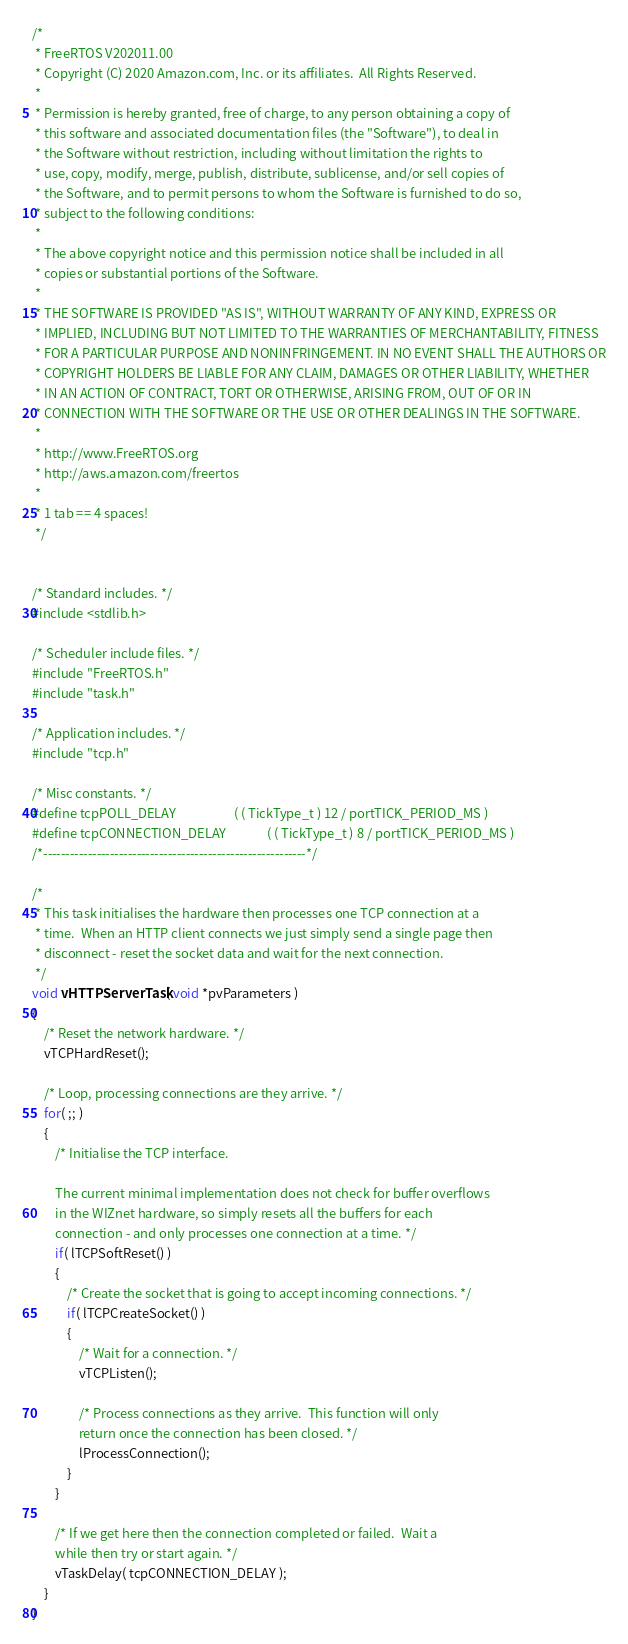<code> <loc_0><loc_0><loc_500><loc_500><_C_>/*
 * FreeRTOS V202011.00
 * Copyright (C) 2020 Amazon.com, Inc. or its affiliates.  All Rights Reserved.
 *
 * Permission is hereby granted, free of charge, to any person obtaining a copy of
 * this software and associated documentation files (the "Software"), to deal in
 * the Software without restriction, including without limitation the rights to
 * use, copy, modify, merge, publish, distribute, sublicense, and/or sell copies of
 * the Software, and to permit persons to whom the Software is furnished to do so,
 * subject to the following conditions:
 *
 * The above copyright notice and this permission notice shall be included in all
 * copies or substantial portions of the Software.
 *
 * THE SOFTWARE IS PROVIDED "AS IS", WITHOUT WARRANTY OF ANY KIND, EXPRESS OR
 * IMPLIED, INCLUDING BUT NOT LIMITED TO THE WARRANTIES OF MERCHANTABILITY, FITNESS
 * FOR A PARTICULAR PURPOSE AND NONINFRINGEMENT. IN NO EVENT SHALL THE AUTHORS OR
 * COPYRIGHT HOLDERS BE LIABLE FOR ANY CLAIM, DAMAGES OR OTHER LIABILITY, WHETHER
 * IN AN ACTION OF CONTRACT, TORT OR OTHERWISE, ARISING FROM, OUT OF OR IN
 * CONNECTION WITH THE SOFTWARE OR THE USE OR OTHER DEALINGS IN THE SOFTWARE.
 *
 * http://www.FreeRTOS.org
 * http://aws.amazon.com/freertos
 *
 * 1 tab == 4 spaces!
 */


/* Standard includes. */
#include <stdlib.h>

/* Scheduler include files. */
#include "FreeRTOS.h"
#include "task.h"

/* Application includes. */
#include "tcp.h"

/* Misc constants. */
#define tcpPOLL_DELAY					( ( TickType_t ) 12 / portTICK_PERIOD_MS )
#define tcpCONNECTION_DELAY				( ( TickType_t ) 8 / portTICK_PERIOD_MS )
/*-----------------------------------------------------------*/

/*
 * This task initialises the hardware then processes one TCP connection at a
 * time.  When an HTTP client connects we just simply send a single page then
 * disconnect - reset the socket data and wait for the next connection.
 */
void vHTTPServerTask( void *pvParameters )
{
	/* Reset the network hardware. */
	vTCPHardReset();

	/* Loop, processing connections are they arrive. */
	for( ;; )
	{
		/* Initialise the TCP interface.

		The current minimal implementation does not check for buffer overflows
		in the WIZnet hardware, so simply resets all the buffers for each
		connection - and only processes one connection at a time. */
		if( lTCPSoftReset() )
		{	  
			/* Create the socket that is going to accept incoming connections. */
			if( lTCPCreateSocket() )
			{
				/* Wait for a connection. */
				vTCPListen();

				/* Process connections as they arrive.  This function will only
				return once the connection has been closed. */
				lProcessConnection();
			}
		}

		/* If we get here then the connection completed or failed.  Wait a 
		while then try or start again. */
		vTaskDelay( tcpCONNECTION_DELAY );		
	}
}

</code> 